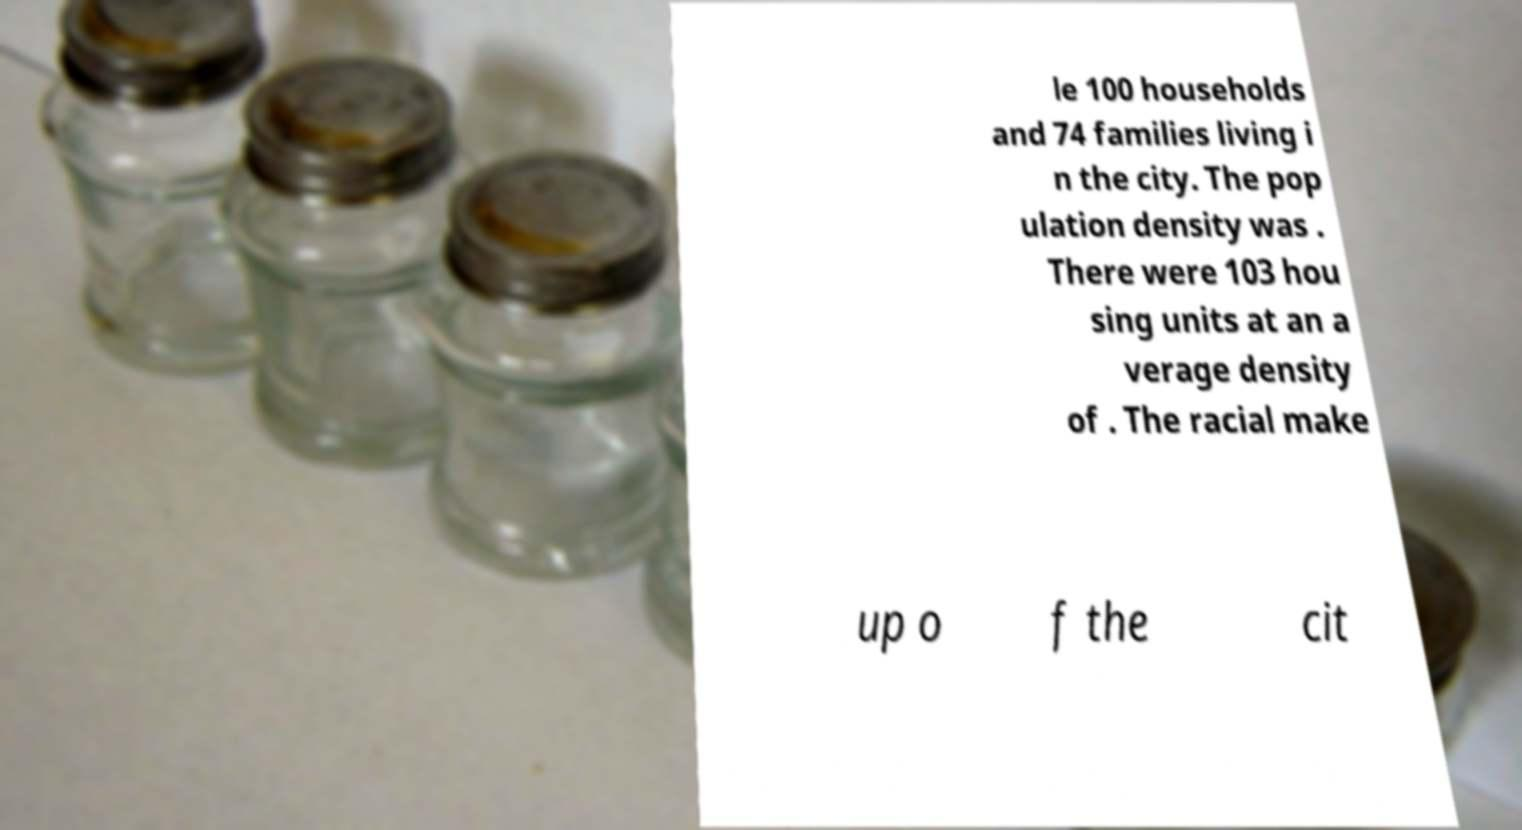Could you extract and type out the text from this image? le 100 households and 74 families living i n the city. The pop ulation density was . There were 103 hou sing units at an a verage density of . The racial make up o f the cit 